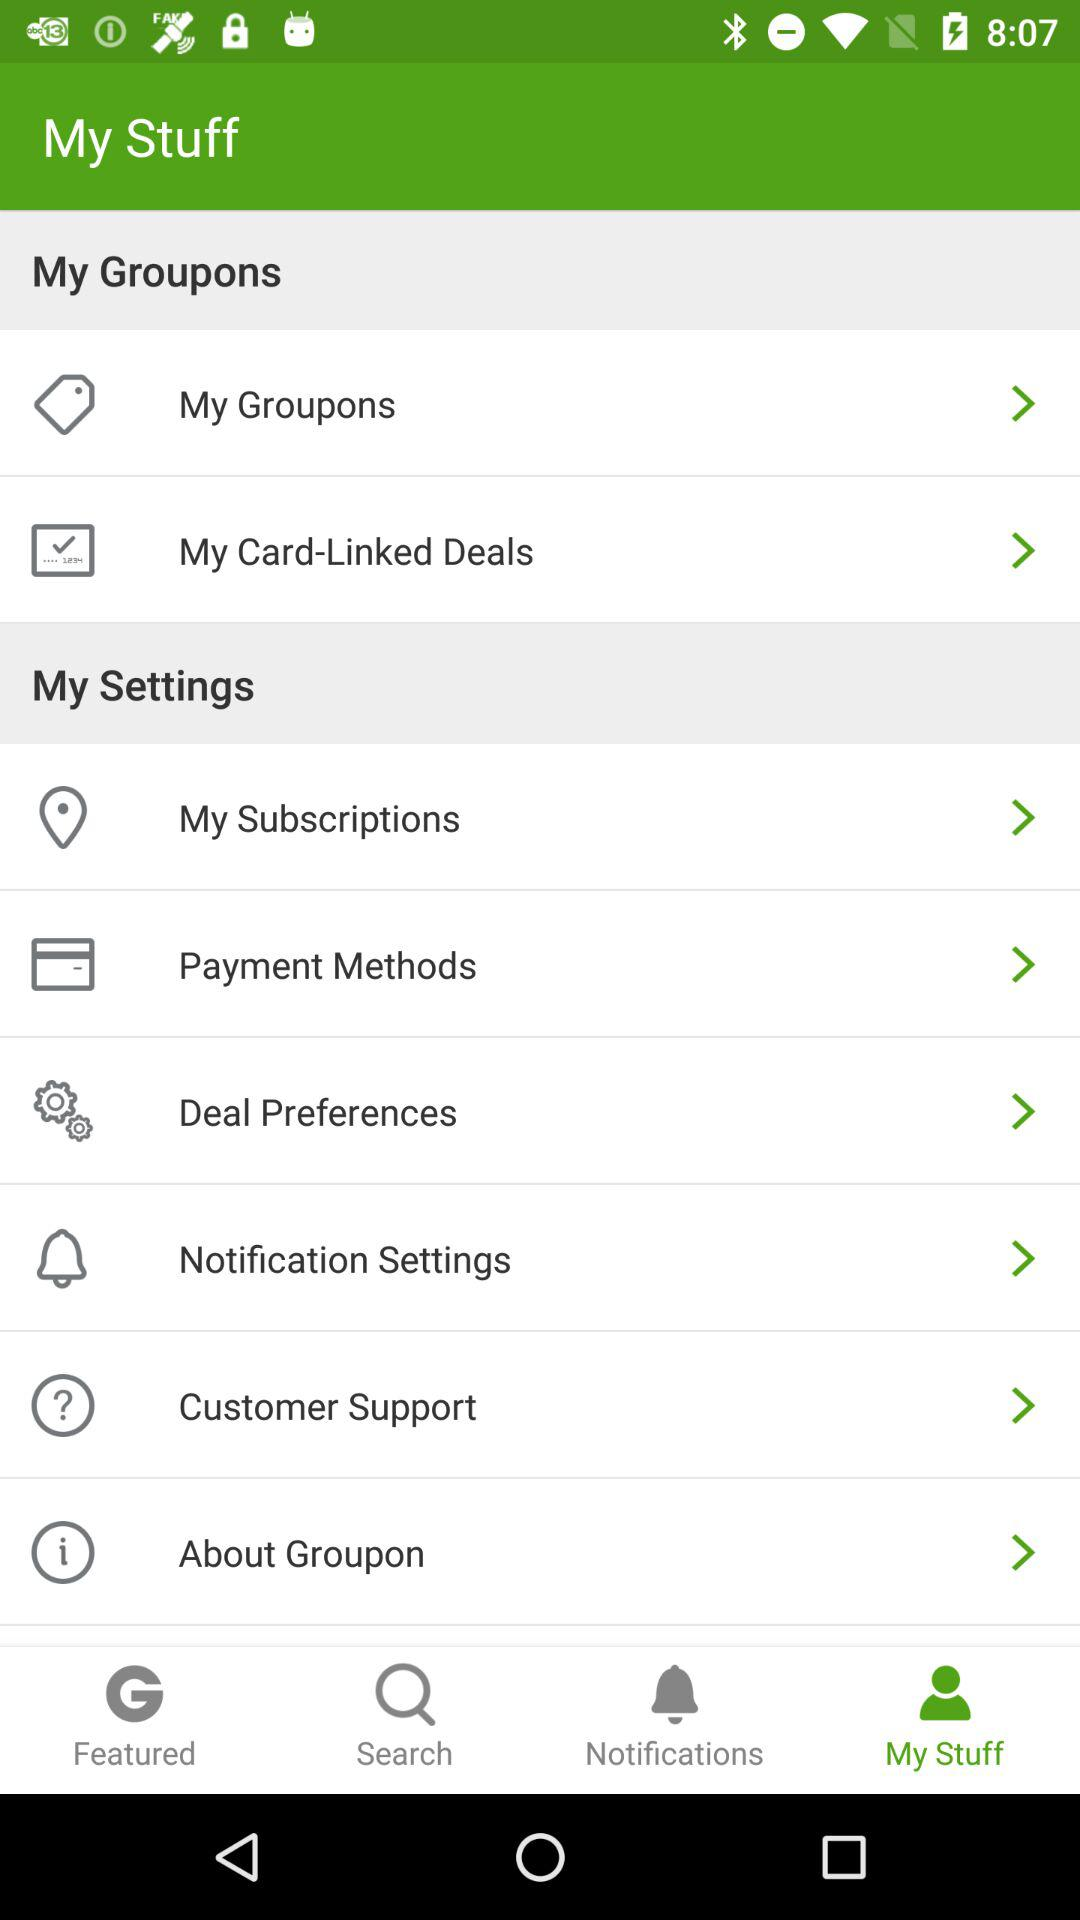Which option is selected? The selected option is "My Stuff". 